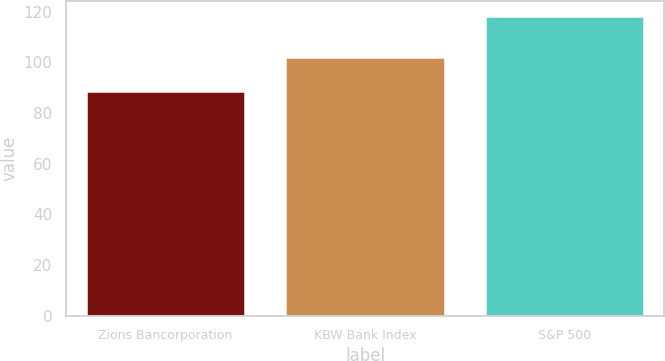Convert chart to OTSL. <chart><loc_0><loc_0><loc_500><loc_500><bar_chart><fcel>Zions Bancorporation<fcel>KBW Bank Index<fcel>S&P 500<nl><fcel>88.7<fcel>102.2<fcel>118.4<nl></chart> 